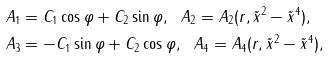<formula> <loc_0><loc_0><loc_500><loc_500>& A _ { 1 } = C _ { 1 } \cos \varphi + C _ { 2 } \sin \varphi , \ \ A _ { 2 } = A _ { 2 } ( r , \tilde { x } ^ { 2 } - \tilde { x } ^ { 4 } ) , \\ & A _ { 3 } = - C _ { 1 } \sin \varphi + C _ { 2 } \cos \varphi , \ \ A _ { 4 } = A _ { 4 } ( r , \tilde { x } ^ { 2 } - \tilde { x } ^ { 4 } ) ,</formula> 